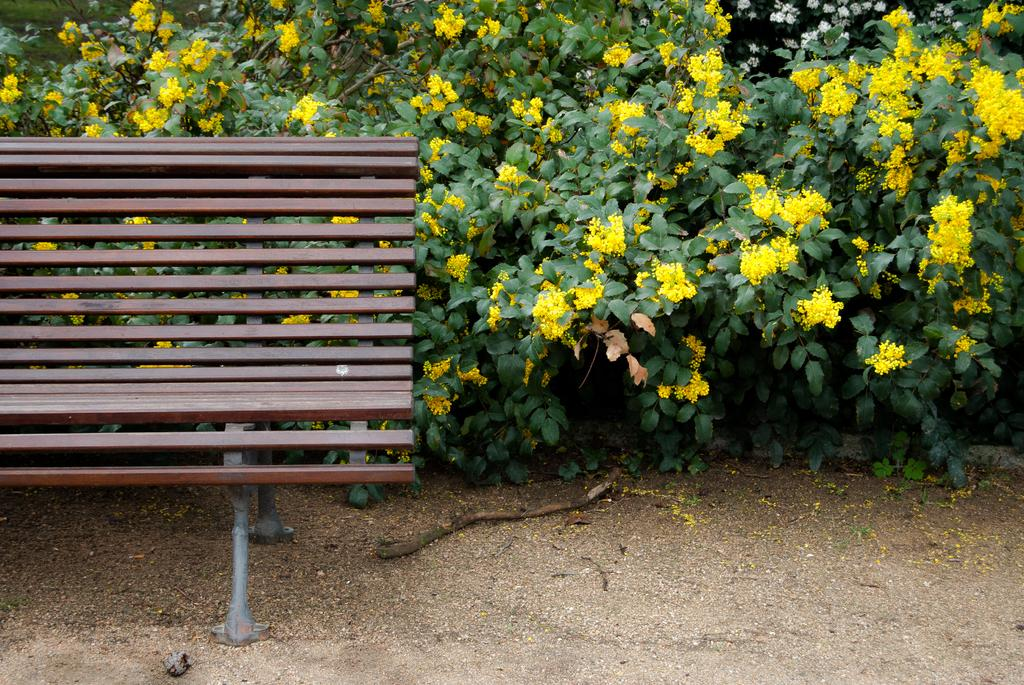What type of living organisms can be seen in the image? Flowers and plants can be seen in the image. What type of object is present in the image that people might sit on? There is a bench in the image. What type of brake system can be seen on the bench in the image? There is no brake system present on the bench in the image. How many boys are visible in the image? There is no boy present in the image. 